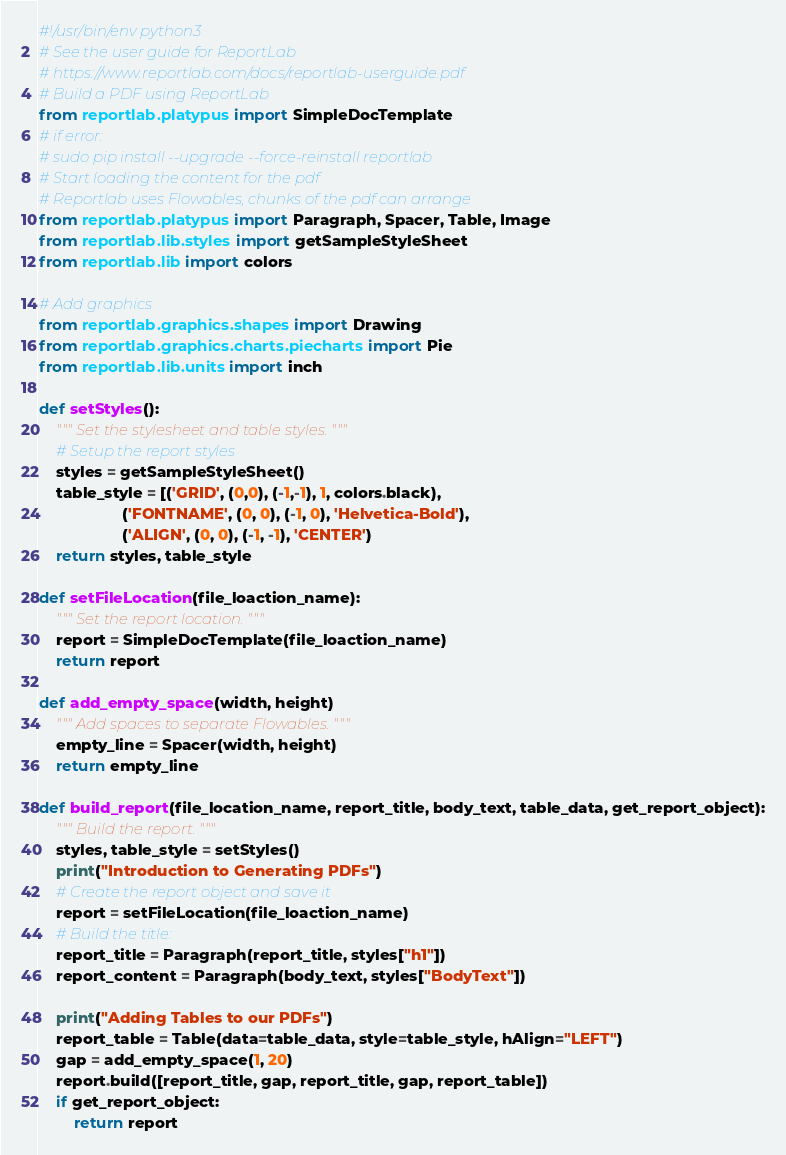Convert code to text. <code><loc_0><loc_0><loc_500><loc_500><_Python_>#!/usr/bin/env python3
# See the user guide for ReportLab
# https://www.reportlab.com/docs/reportlab-userguide.pdf
# Build a PDF using ReportLab
from reportlab.platypus import SimpleDocTemplate
# if error:
# sudo pip install --upgrade --force-reinstall reportlab
# Start loading the content for the pdf
# Reportlab uses Flowables, chunks of the pdf can arrange
from reportlab.platypus import Paragraph, Spacer, Table, Image
from reportlab.lib.styles import getSampleStyleSheet
from reportlab.lib import colors

# Add graphics
from reportlab.graphics.shapes import Drawing
from reportlab.graphics.charts.piecharts import Pie
from reportlab.lib.units import inch

def setStyles():
    """ Set the stylesheet and table styles. """
    # Setup the report styles
    styles = getSampleStyleSheet()
    table_style = [('GRID', (0,0), (-1,-1), 1, colors.black),
                   ('FONTNAME', (0, 0), (-1, 0), 'Helvetica-Bold'),
                   ('ALIGN', (0, 0), (-1, -1), 'CENTER')
    return styles, table_style

def setFileLocation(file_loaction_name):
    """ Set the report location. """
    report = SimpleDocTemplate(file_loaction_name)
    return report

def add_empty_space(width, height)
    """ Add spaces to separate Flowables. """
    empty_line = Spacer(width, height)
    return empty_line

def build_report(file_location_name, report_title, body_text, table_data, get_report_object):
    """ Build the report. """
    styles, table_style = setStyles()
    print("Introduction to Generating PDFs")
    # Create the report object and save it
    report = setFileLocation(file_loaction_name)
    # Build the title:
    report_title = Paragraph(report_title, styles["h1"])
    report_content = Paragraph(body_text, styles["BodyText"])

    print("Adding Tables to our PDFs")
    report_table = Table(data=table_data, style=table_style, hAlign="LEFT")
    gap = add_empty_space(1, 20)
    report.build([report_title, gap, report_title, gap, report_table])
    if get_report_object:
        return report</code> 